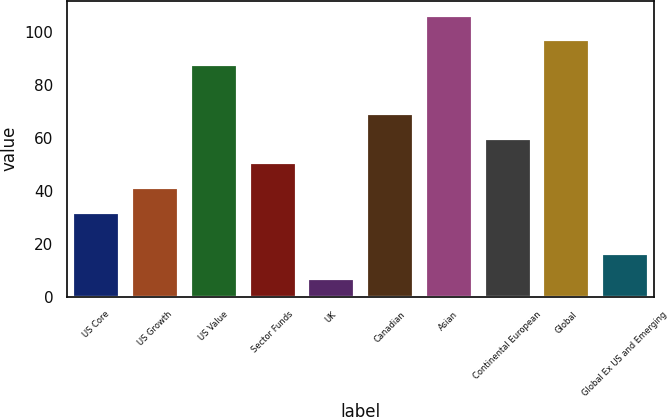<chart> <loc_0><loc_0><loc_500><loc_500><bar_chart><fcel>US Core<fcel>US Growth<fcel>US Value<fcel>Sector Funds<fcel>UK<fcel>Canadian<fcel>Asian<fcel>Continental European<fcel>Global<fcel>Global Ex US and Emerging<nl><fcel>32<fcel>41.3<fcel>87.8<fcel>50.6<fcel>7<fcel>69.2<fcel>106.4<fcel>59.9<fcel>97.1<fcel>16.3<nl></chart> 